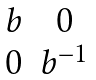<formula> <loc_0><loc_0><loc_500><loc_500>\begin{matrix} b & 0 \\ 0 & b ^ { - 1 } \end{matrix}</formula> 